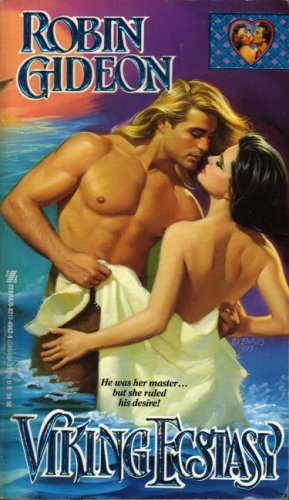Who wrote this book? This book, featuring a dramatic romance theme on its cover, was written by Robin Gideon. 